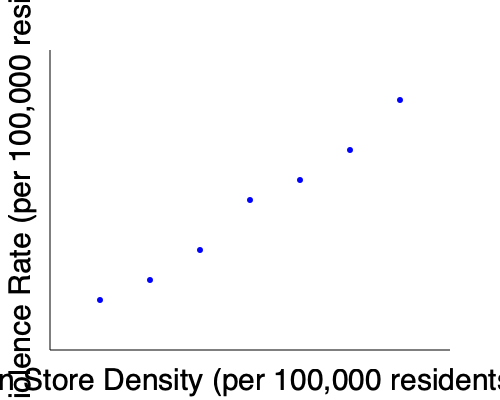Based on the scatter plot showing the relationship between gun store density and gun violence rates across different counties, what type of correlation appears to exist between these two variables? How might this data inform policies aimed at reducing gun violence? To analyze the correlation between gun store density and gun violence rates:

1. Observe the overall trend: As we move from left to right (increasing gun store density), the points tend to move downward (decreasing gun violence rate).

2. Identify the correlation type: This pattern suggests a negative or inverse correlation between the variables.

3. Strength of correlation: The points form a fairly consistent downward trend, indicating a moderately strong correlation.

4. Potential implications:
   a) Counties with higher gun store density tend to have lower gun violence rates.
   b) This counterintuitive relationship could be due to various factors:
      - Stricter regulations in high-density areas
      - Better security measures in areas with more gun stores
      - Socioeconomic factors influencing both variables

5. Policy considerations:
   a) The data suggests that simply reducing gun store density may not lead to lower gun violence rates.
   b) Policymakers should investigate other factors contributing to lower violence rates in high-density areas.
   c) Focus on comprehensive approaches, including education, mental health support, and targeted interventions in high-risk areas.

6. Limitations:
   a) Correlation does not imply causation.
   b) Other variables not shown in this plot may influence the relationship.
   c) The data represents counties, which may have varying population sizes and characteristics.

In conclusion, the scatter plot reveals a moderately strong negative correlation between gun store density and gun violence rates, challenging simplistic assumptions about gun availability and violence.
Answer: Moderately strong negative correlation; suggests need for comprehensive policies beyond gun store regulation. 